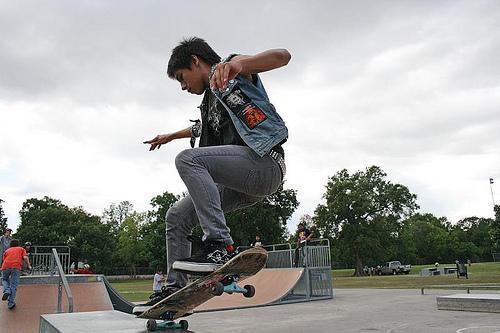How many people can you see?
Give a very brief answer. 1. 